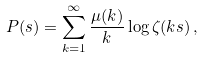Convert formula to latex. <formula><loc_0><loc_0><loc_500><loc_500>P ( s ) = \sum _ { k = 1 } ^ { \infty } \frac { \mu ( k ) } { k } \log \zeta ( k s ) \, ,</formula> 